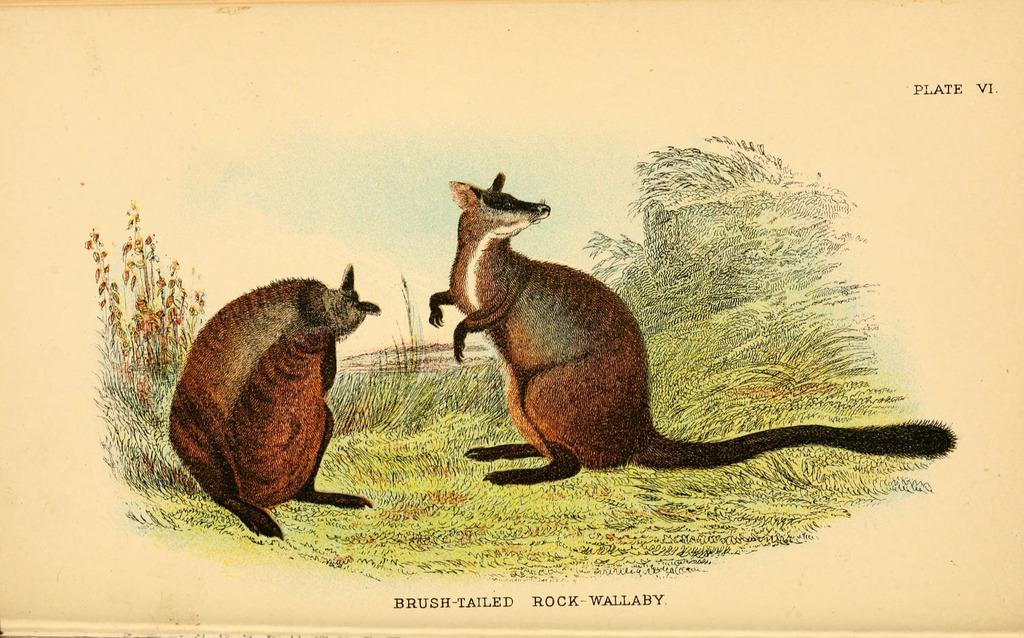What is the medium used to create the image? The image is painted. How many animals are present in the image? There are two animals in the image. What is the setting of the image? The animals are standing on grassland. What type of vegetation can be seen in the grassland? There are plants in the grassland. What can be found at the bottom of the image? There is text at the bottom of the image. How far away is the chin of the animal in the image? There is no chin visible in the image, as the animals are not human. 